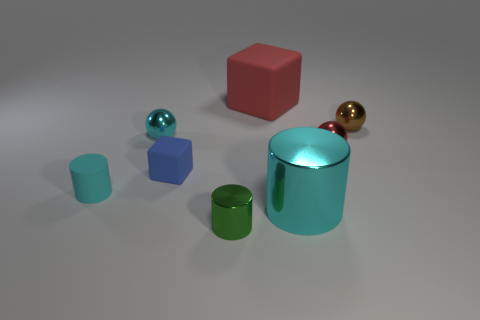What material is the tiny cylinder to the right of the cyan metal thing left of the red thing that is left of the cyan shiny cylinder?
Keep it short and to the point. Metal. How many other objects are there of the same size as the brown sphere?
Offer a very short reply. 5. What size is the ball that is the same color as the rubber cylinder?
Offer a terse response. Small. Is the number of small balls on the right side of the small green metal cylinder greater than the number of big brown cylinders?
Your response must be concise. Yes. Are there any metallic things of the same color as the big rubber cube?
Your answer should be very brief. Yes. There is a object that is the same size as the red matte cube; what color is it?
Keep it short and to the point. Cyan. There is a red object behind the small brown ball; how many matte cylinders are to the right of it?
Ensure brevity in your answer.  0. How many things are either tiny cylinders that are on the left side of the small rubber cube or cyan matte blocks?
Keep it short and to the point. 1. How many tiny red spheres have the same material as the brown object?
Offer a very short reply. 1. What is the shape of the large metallic object that is the same color as the rubber cylinder?
Keep it short and to the point. Cylinder. 